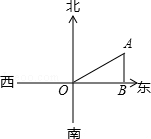Can you determine the exact dimensions of the triangle formed by the water tower, Xiaoya's house, and the highway in the image? Certainly! In the image provided, the triangle AOB represents the positions of the water tower (A), Xiaoya's house (O), and a point on the highway (B). Since OA represents the distance from the house to the water tower, and we know it’s 2000.0 meters, we can determine the triangle’s dimensions. Specifically, AB corresponds to the distance from the water tower to the highway, which we have calculated using the sine of the 60-degree angle, giving us 1000√3 meters. The length of OB would be the base of the triangle and can be determined using the cosine of 60 degrees, hence OB = OA * cos(60) = 2000 * 0.5 = 1000 meters. So, the dimensions of the triangle are OA = 2000.0 meters, AB = 1000√3 meters, and OB = 1000.0 meters. 